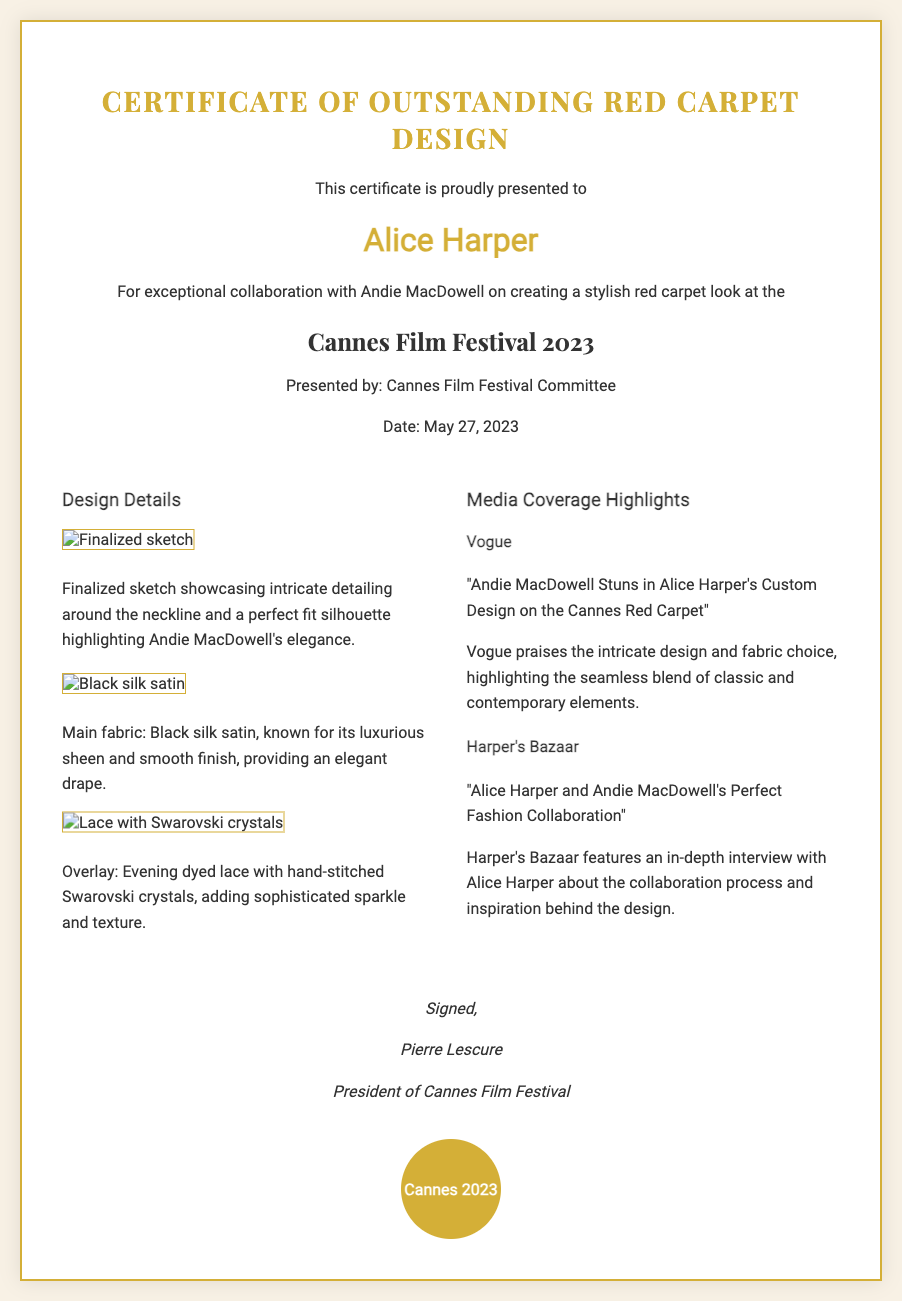What is the title of the certificate? The title of the certificate is clearly stated at the top of the document.
Answer: Certificate of Outstanding Red Carpet Design Who is the recipient of the certificate? The recipient's name is highlighted in the document, specifying who received the certificate.
Answer: Alice Harper What is the date of the event? The document specifies the date of the Cannes Film Festival when the award was presented.
Answer: May 27, 2023 What main fabric was used in the design? The document provides details about the main fabric, identifying it specifically.
Answer: Black silk satin Which publication praised the design? The document lists media outlets that covered the design, one of which is mentioned first.
Answer: Vogue What notable feature does the overlay fabric have? The document describes the overlay fabric, mentioning a specific detail that enhances its elegance.
Answer: Hand-stitched Swarovski crystals Who signed the certificate? The document includes the name of the individual who signed the certificate, indicating their position.
Answer: Pierre Lescure What festival is this certificate associated with? The document specifies the name of the festival related to the certificate.
Answer: Cannes Film Festival 